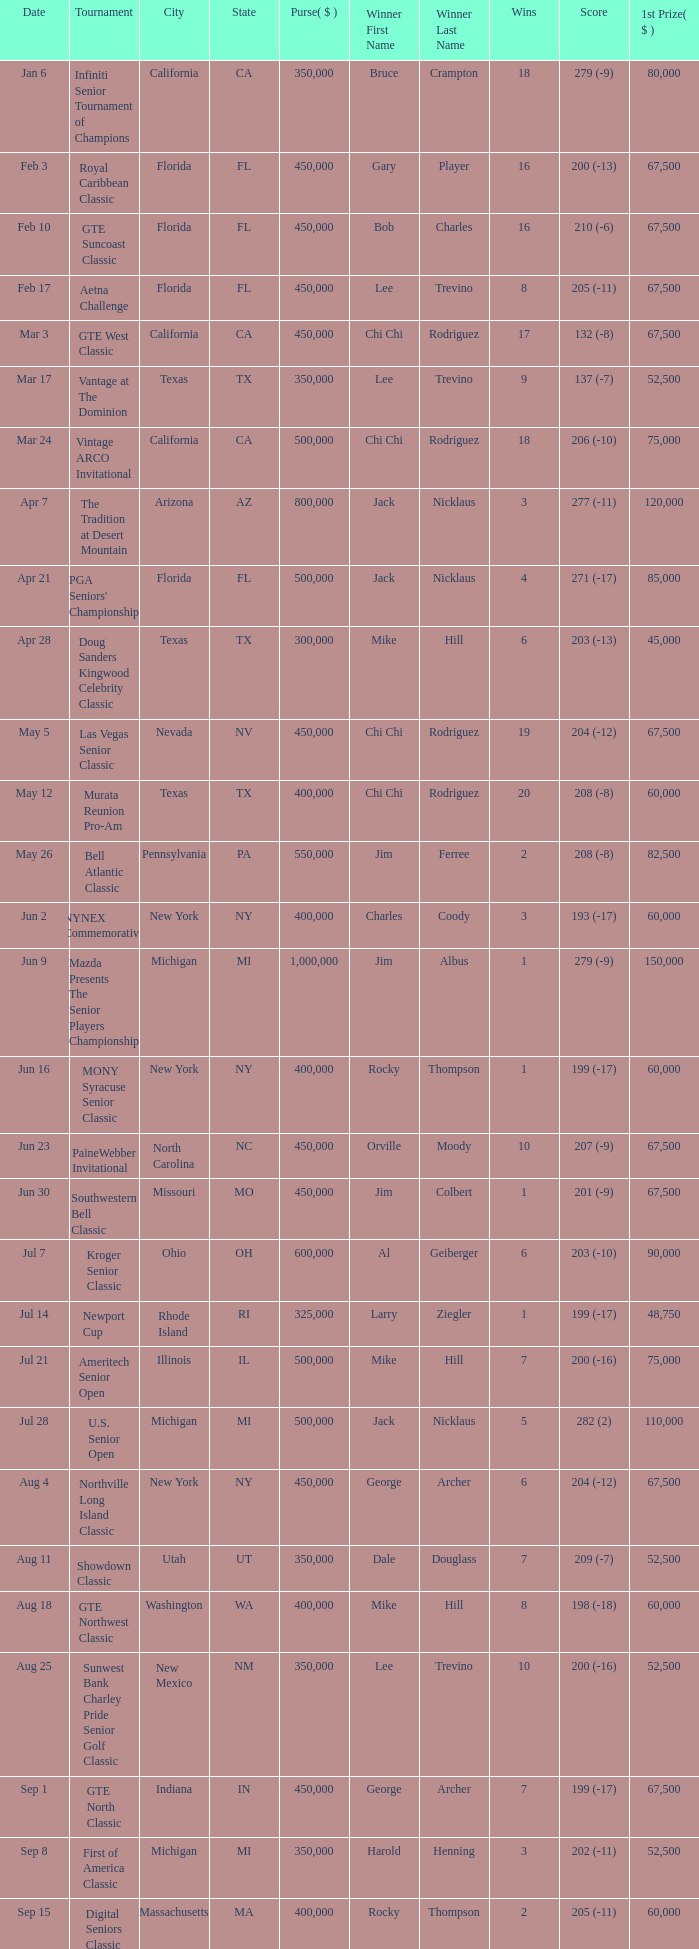Where was the security pacific senior classic? California. 